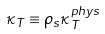Convert formula to latex. <formula><loc_0><loc_0><loc_500><loc_500>\kappa _ { T } \equiv \rho _ { s } \kappa _ { T } ^ { p h y s }</formula> 